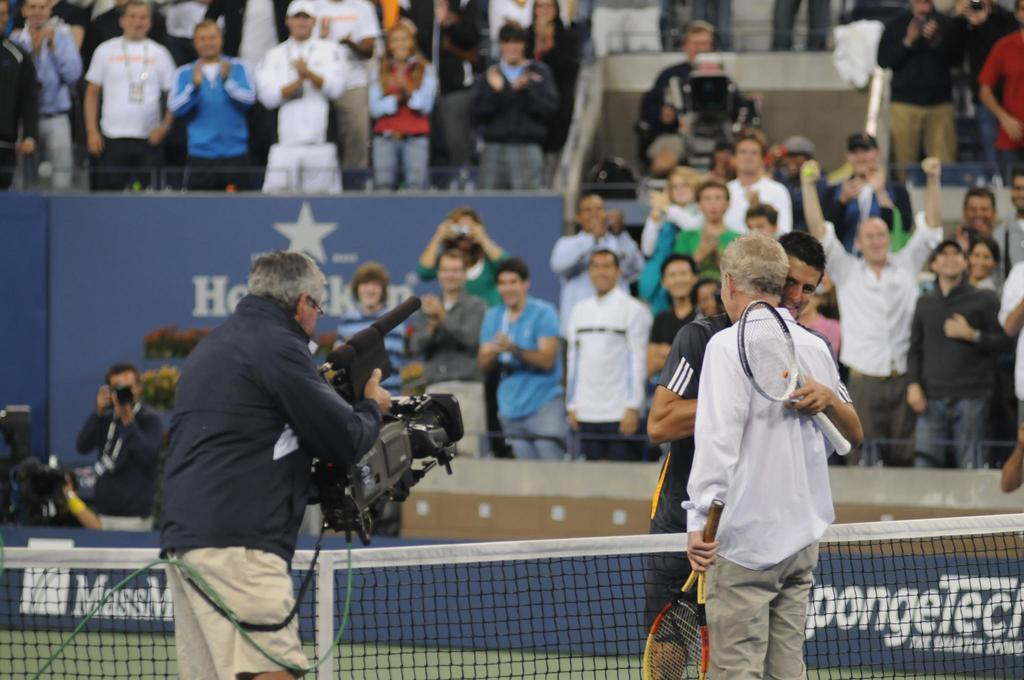<image>
Offer a succinct explanation of the picture presented. A camera man records footage of a tennis match with a SpongeTech banner in the background. 